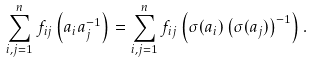Convert formula to latex. <formula><loc_0><loc_0><loc_500><loc_500>\sum _ { i , j = 1 } ^ { n } f _ { i j } \left ( a _ { i } a _ { j } ^ { - 1 } \right ) = \sum _ { i , j = 1 } ^ { n } f _ { i j } \left ( \sigma ( a _ { i } ) \left ( \sigma ( a _ { j } ) \right ) ^ { - 1 } \right ) .</formula> 